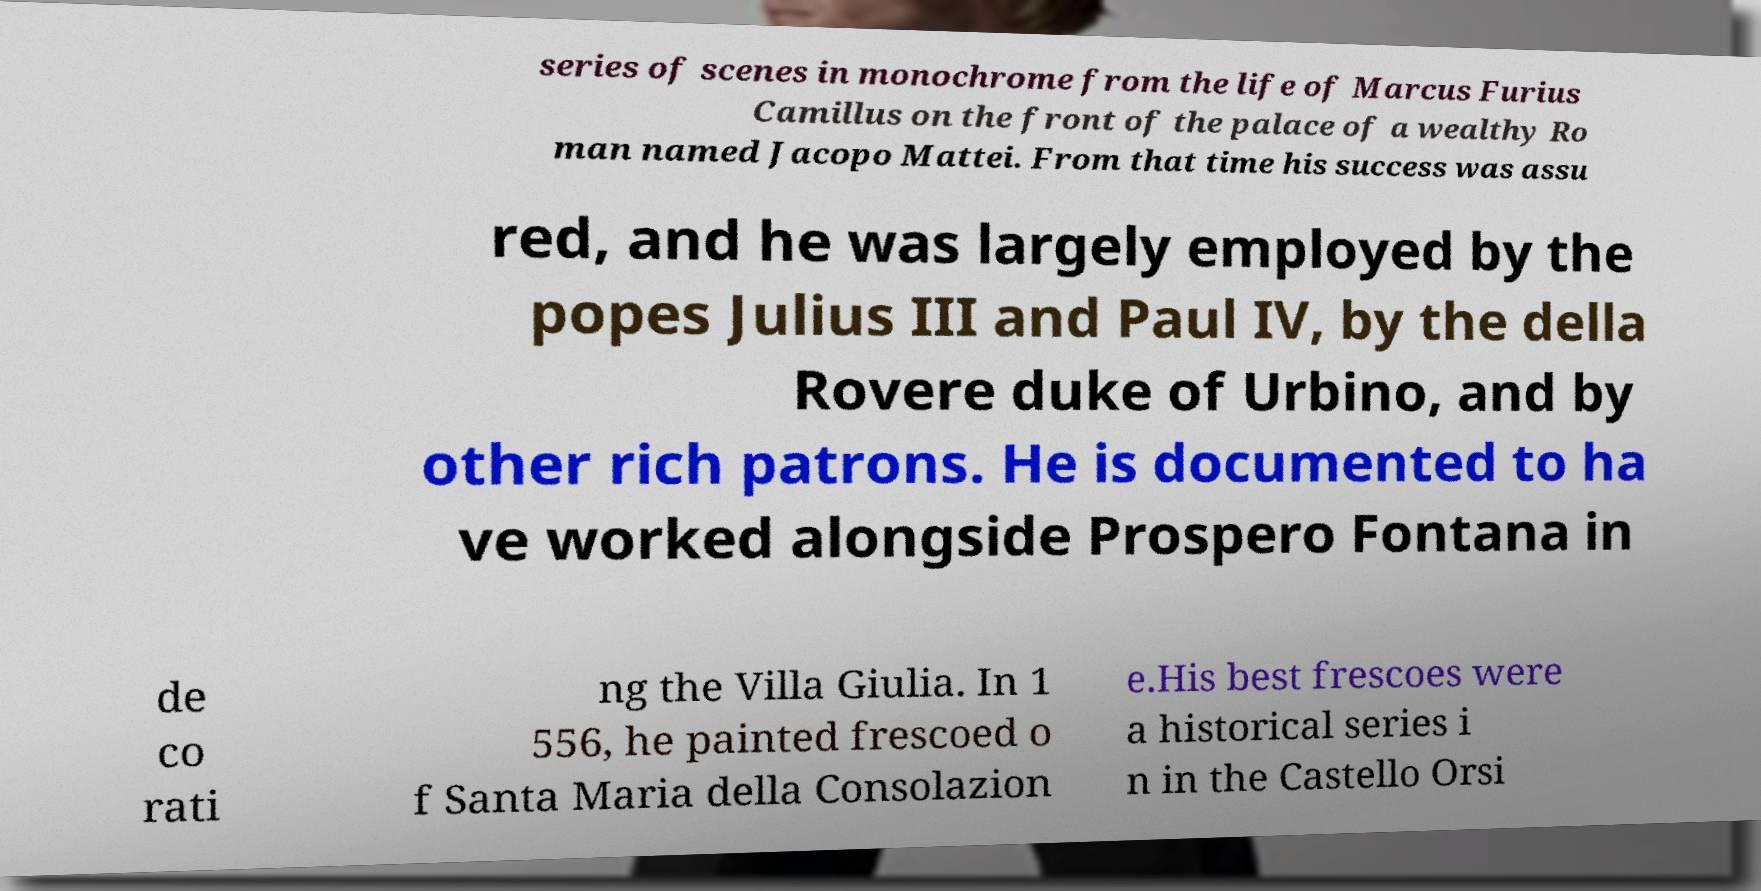Can you accurately transcribe the text from the provided image for me? series of scenes in monochrome from the life of Marcus Furius Camillus on the front of the palace of a wealthy Ro man named Jacopo Mattei. From that time his success was assu red, and he was largely employed by the popes Julius III and Paul IV, by the della Rovere duke of Urbino, and by other rich patrons. He is documented to ha ve worked alongside Prospero Fontana in de co rati ng the Villa Giulia. In 1 556, he painted frescoed o f Santa Maria della Consolazion e.His best frescoes were a historical series i n in the Castello Orsi 